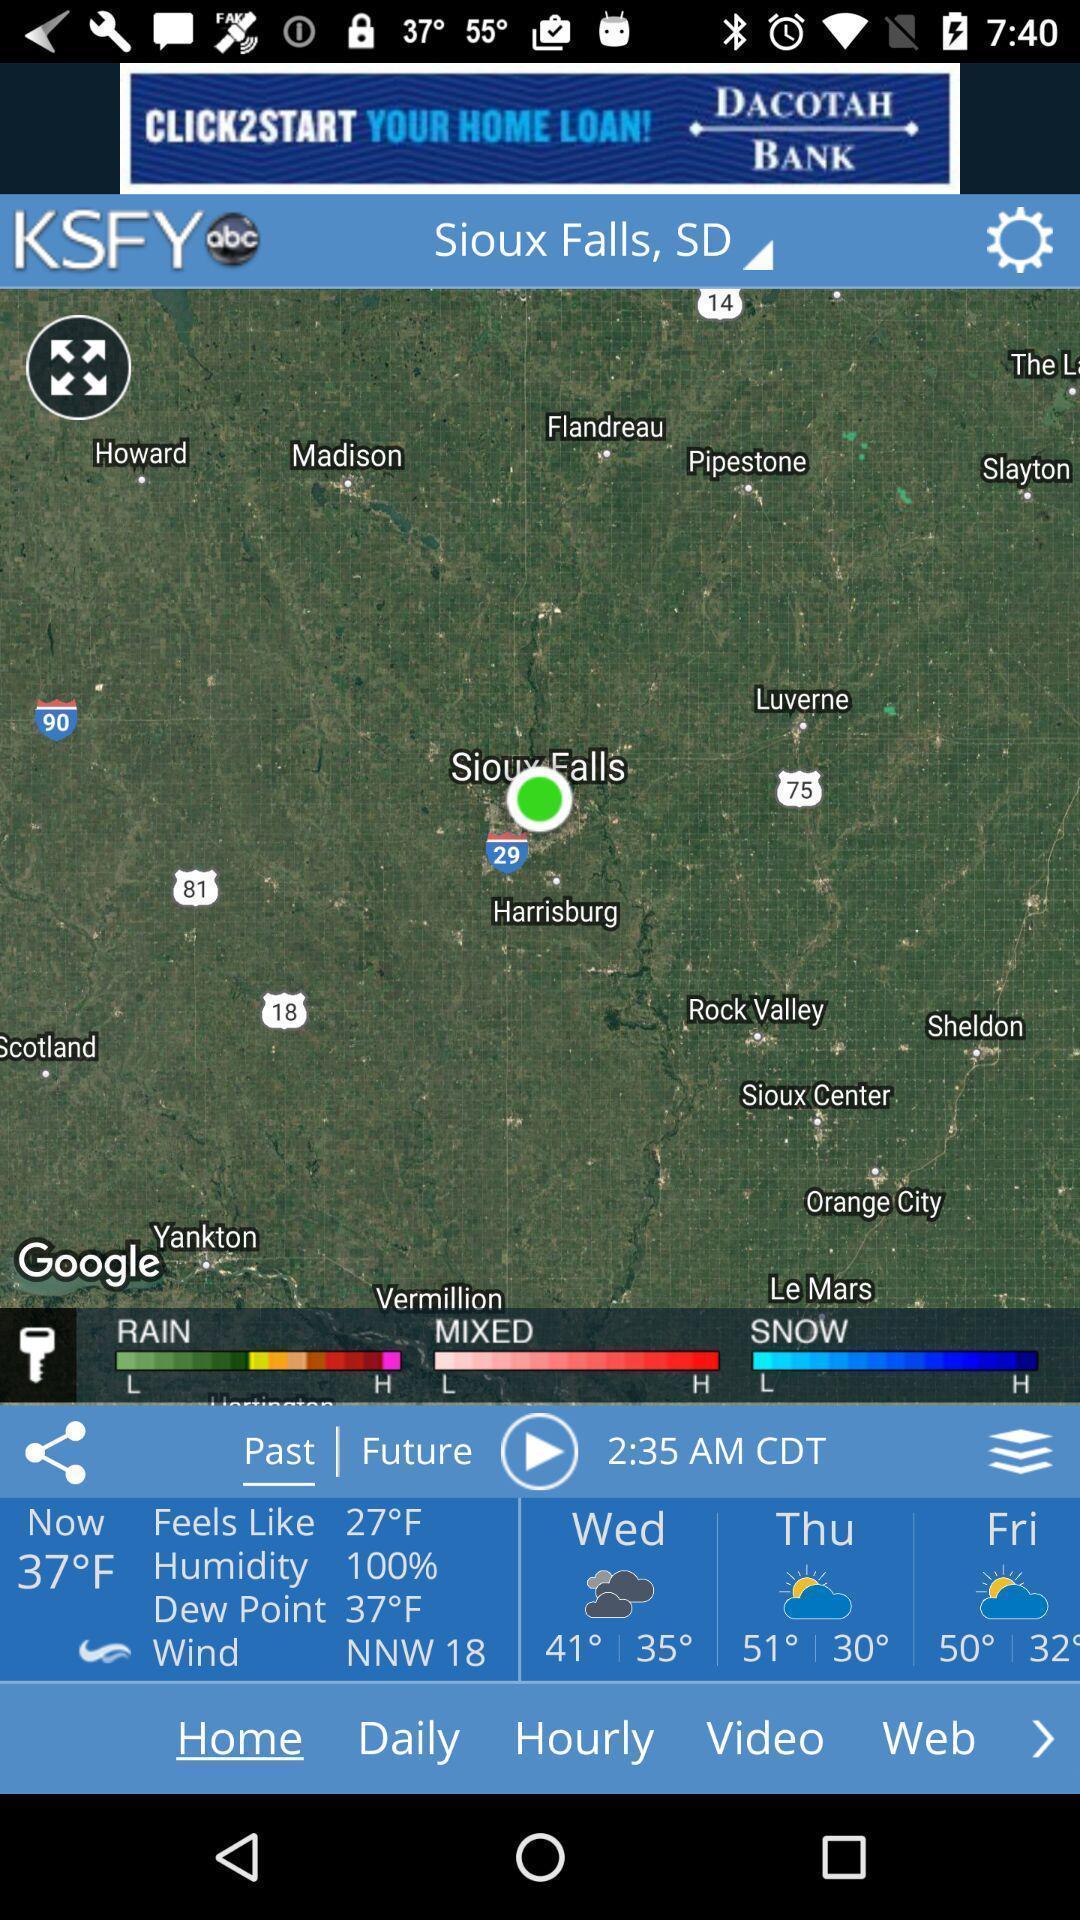Provide a textual representation of this image. Screen shows weather details in weather app. 